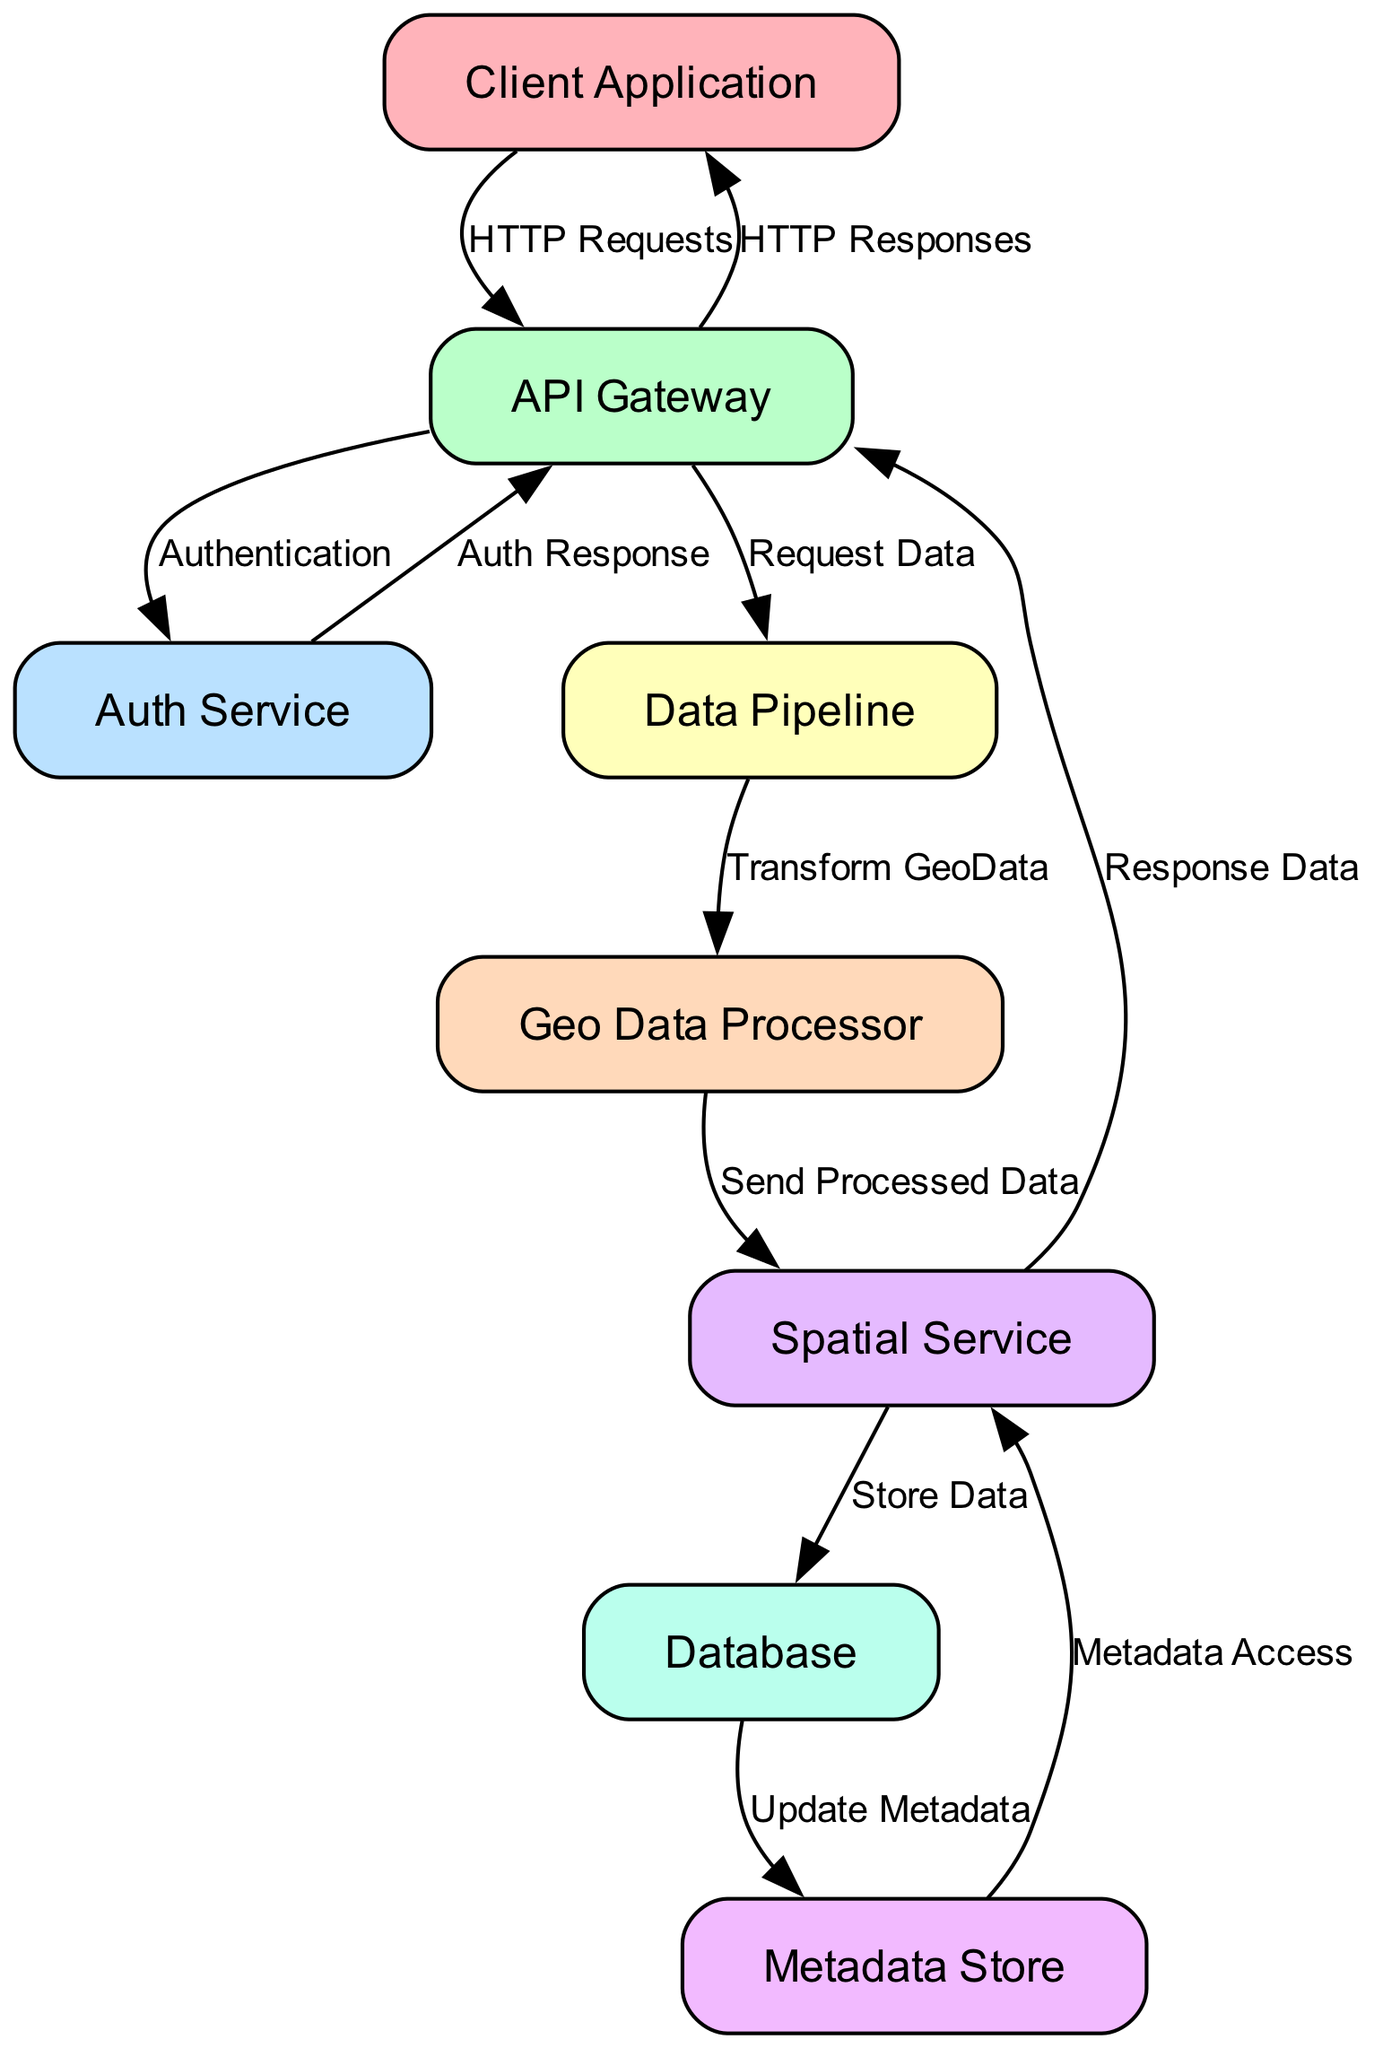What is the total number of nodes in the diagram? Counting all the nodes listed in the data, we see there are eight unique nodes: Client Application, API Gateway, Auth Service, Data Pipeline, Geo Data Processor, Spatial Service, Database, and Metadata Store.
Answer: Eight Which node receives HTTP requests from the client application? The diagram shows an edge labeled "HTTP Requests" connecting the Client Application to the API Gateway, indicating that the API Gateway is the node that receives these requests.
Answer: API Gateway How many edges are originating from the spatial service? By examining the edges, we notice that the Spatial Service has three outgoing edges: to the Database (Store Data), to the API Gateway (Response Data), and there's no additional outgoing connection. Therefore, the total count is three.
Answer: Three What type of response does the Auth Service send back to the API Gateway? Referring to the specified edge, the relationship is labeled as "Auth Response," indicating the nature of the response sent back after authentication.
Answer: Auth Response What is the purpose of the Data Pipeline in this architecture? The edge connecting the API Gateway to the Data Pipeline is labeled "Request Data," and subsequently, the Data Pipeline transforms the geo data before sending it to the Geo Data Processor. This indicates that the Data Pipeline is responsible for handling and transforming incoming data.
Answer: Transform GeoData Which node is responsible for accessing metadata? The diagram shows an edge labeled "Metadata Access" from the Metadata Store to the Spatial Service, indicating that the Spatial Service is the node tasked with accessing metadata stored in the Metadata Store.
Answer: Spatial Service Identify the relationship between the Database and the Metadata Store. The edge between these two nodes is labeled "Update Metadata," indicating that the Database is responsible for updating metadata stored in the Metadata Store.
Answer: Update Metadata What node does the Geo Data Processor send processed data to? The flow illustrated in the diagram indicates that the Geo Data Processor sends the processed data directly to the Spatial Service, representing their direct connection.
Answer: Spatial Service 